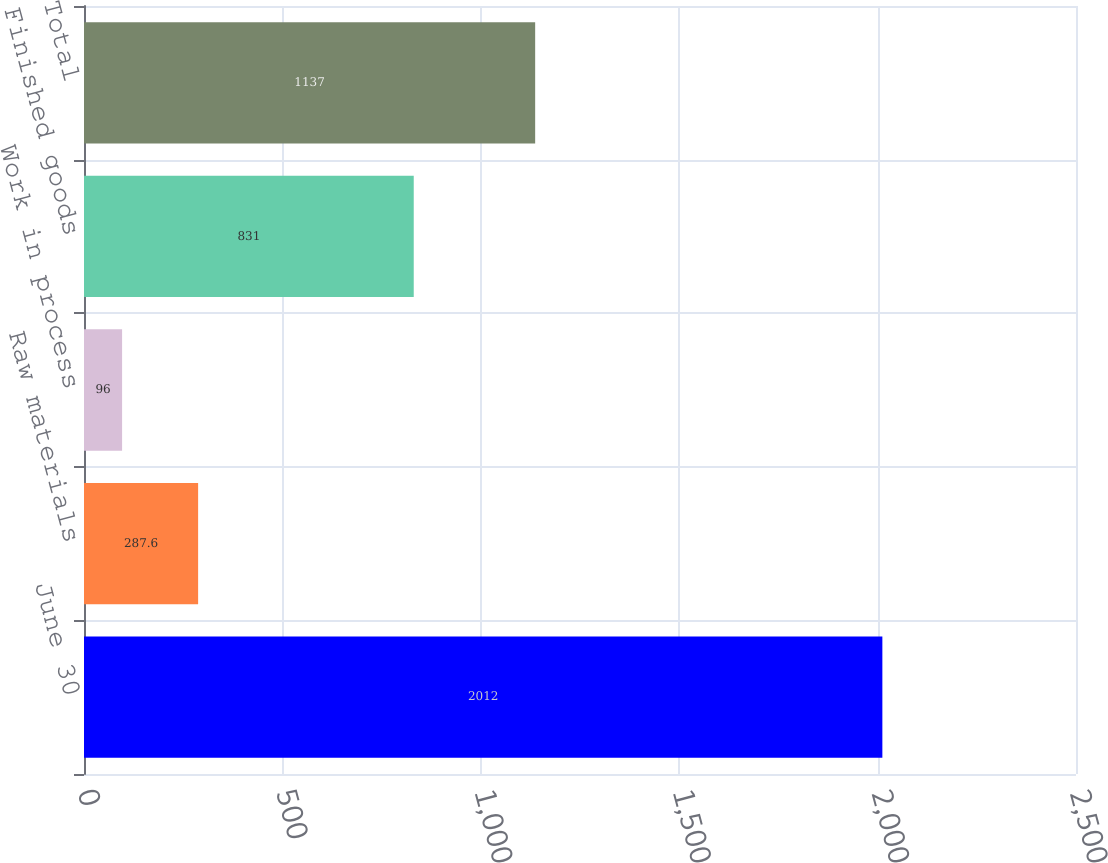Convert chart. <chart><loc_0><loc_0><loc_500><loc_500><bar_chart><fcel>June 30<fcel>Raw materials<fcel>Work in process<fcel>Finished goods<fcel>Total<nl><fcel>2012<fcel>287.6<fcel>96<fcel>831<fcel>1137<nl></chart> 